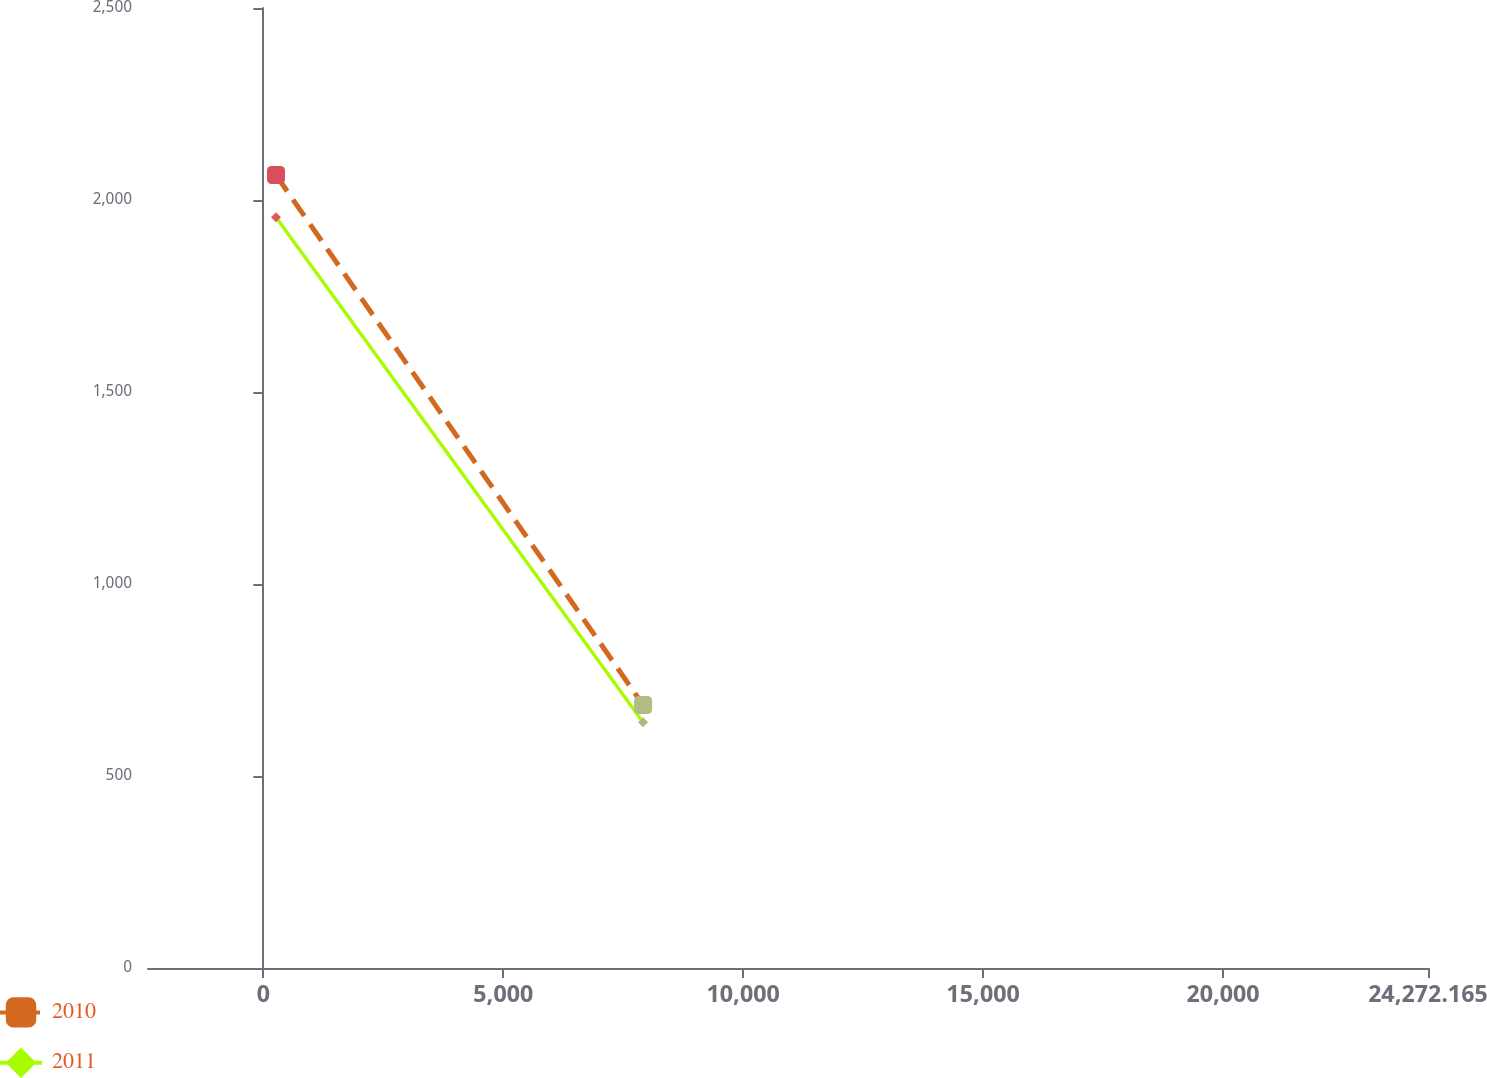Convert chart to OTSL. <chart><loc_0><loc_0><loc_500><loc_500><line_chart><ecel><fcel>2010<fcel>2011<nl><fcel>264.35<fcel>2064.99<fcel>1955.27<nl><fcel>7914.22<fcel>684.85<fcel>640.15<nl><fcel>26939.7<fcel>28.24<fcel>34.39<nl></chart> 